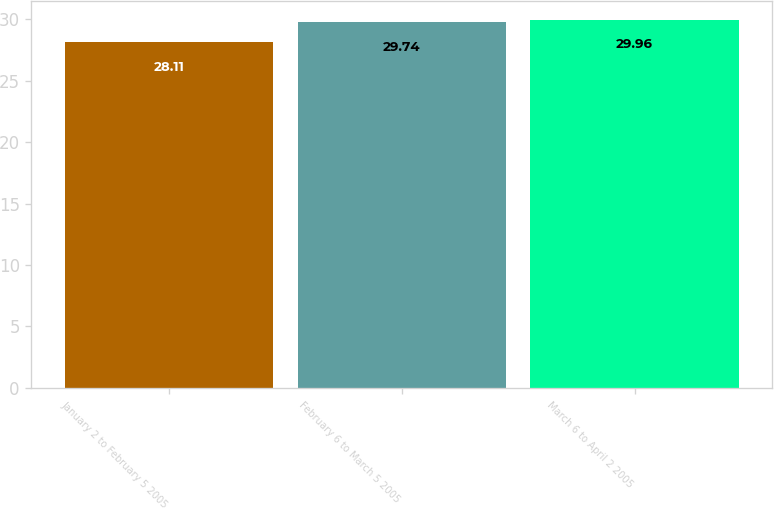Convert chart. <chart><loc_0><loc_0><loc_500><loc_500><bar_chart><fcel>January 2 to February 5 2005<fcel>February 6 to March 5 2005<fcel>March 6 to April 2 2005<nl><fcel>28.11<fcel>29.74<fcel>29.96<nl></chart> 